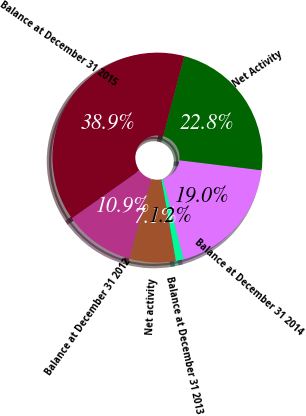<chart> <loc_0><loc_0><loc_500><loc_500><pie_chart><fcel>Balance at December 31 2012<fcel>Net activity<fcel>Balance at December 31 2013<fcel>Balance at December 31 2014<fcel>Net Activity<fcel>Balance at December 31 2015<nl><fcel>10.91%<fcel>7.14%<fcel>1.19%<fcel>19.05%<fcel>22.82%<fcel>38.89%<nl></chart> 